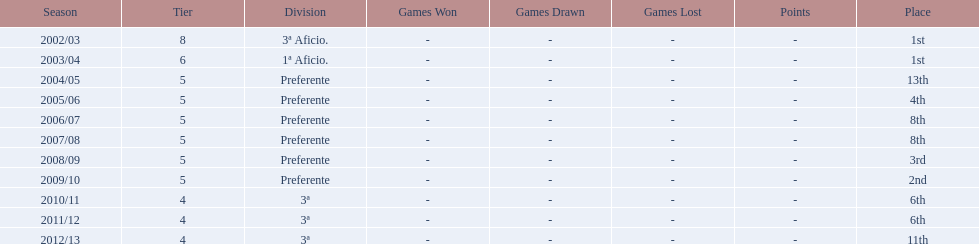What place did the team place in 2010/11? 6th. In what other year did they place 6th? 2011/12. 